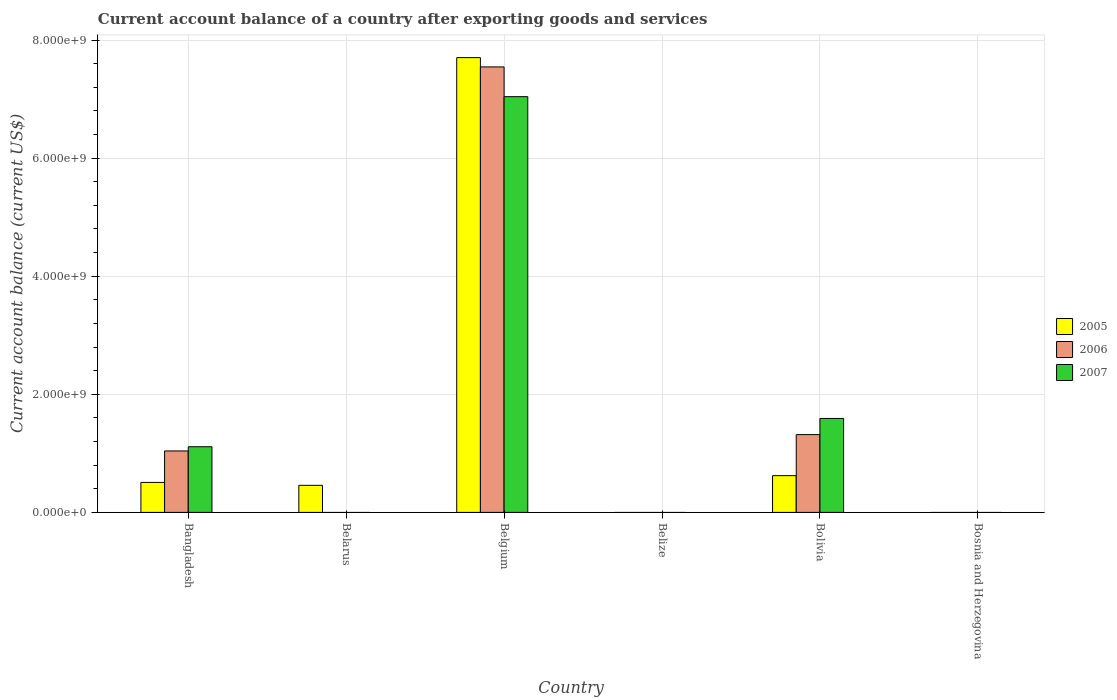How many bars are there on the 6th tick from the left?
Your answer should be very brief. 0. How many bars are there on the 5th tick from the right?
Make the answer very short. 1. What is the label of the 5th group of bars from the left?
Offer a very short reply. Bolivia. In how many cases, is the number of bars for a given country not equal to the number of legend labels?
Give a very brief answer. 3. What is the account balance in 2007 in Bolivia?
Make the answer very short. 1.59e+09. Across all countries, what is the maximum account balance in 2007?
Ensure brevity in your answer.  7.04e+09. Across all countries, what is the minimum account balance in 2007?
Your answer should be compact. 0. What is the total account balance in 2007 in the graph?
Offer a terse response. 9.74e+09. What is the difference between the account balance in 2007 in Bangladesh and that in Belgium?
Your response must be concise. -5.93e+09. What is the difference between the account balance in 2007 in Belarus and the account balance in 2005 in Belgium?
Your answer should be compact. -7.70e+09. What is the average account balance in 2006 per country?
Your response must be concise. 1.65e+09. What is the difference between the account balance of/in 2006 and account balance of/in 2005 in Bolivia?
Offer a very short reply. 6.95e+08. Is the account balance in 2006 in Bangladesh less than that in Belgium?
Your answer should be very brief. Yes. Is the difference between the account balance in 2006 in Bangladesh and Belgium greater than the difference between the account balance in 2005 in Bangladesh and Belgium?
Provide a short and direct response. Yes. What is the difference between the highest and the second highest account balance in 2005?
Provide a succinct answer. 1.15e+08. What is the difference between the highest and the lowest account balance in 2006?
Keep it short and to the point. 7.55e+09. In how many countries, is the account balance in 2005 greater than the average account balance in 2005 taken over all countries?
Offer a very short reply. 1. How many bars are there?
Your response must be concise. 10. How many countries are there in the graph?
Provide a succinct answer. 6. Are the values on the major ticks of Y-axis written in scientific E-notation?
Ensure brevity in your answer.  Yes. What is the title of the graph?
Your response must be concise. Current account balance of a country after exporting goods and services. What is the label or title of the X-axis?
Keep it short and to the point. Country. What is the label or title of the Y-axis?
Offer a very short reply. Current account balance (current US$). What is the Current account balance (current US$) of 2005 in Bangladesh?
Keep it short and to the point. 5.08e+08. What is the Current account balance (current US$) in 2006 in Bangladesh?
Provide a short and direct response. 1.04e+09. What is the Current account balance (current US$) in 2007 in Bangladesh?
Your answer should be very brief. 1.11e+09. What is the Current account balance (current US$) in 2005 in Belarus?
Your response must be concise. 4.59e+08. What is the Current account balance (current US$) in 2005 in Belgium?
Offer a very short reply. 7.70e+09. What is the Current account balance (current US$) in 2006 in Belgium?
Offer a terse response. 7.55e+09. What is the Current account balance (current US$) in 2007 in Belgium?
Offer a very short reply. 7.04e+09. What is the Current account balance (current US$) in 2005 in Belize?
Offer a very short reply. 0. What is the Current account balance (current US$) in 2006 in Belize?
Your answer should be very brief. 0. What is the Current account balance (current US$) of 2007 in Belize?
Offer a very short reply. 0. What is the Current account balance (current US$) of 2005 in Bolivia?
Make the answer very short. 6.22e+08. What is the Current account balance (current US$) in 2006 in Bolivia?
Your response must be concise. 1.32e+09. What is the Current account balance (current US$) in 2007 in Bolivia?
Give a very brief answer. 1.59e+09. Across all countries, what is the maximum Current account balance (current US$) in 2005?
Offer a very short reply. 7.70e+09. Across all countries, what is the maximum Current account balance (current US$) in 2006?
Provide a short and direct response. 7.55e+09. Across all countries, what is the maximum Current account balance (current US$) of 2007?
Offer a very short reply. 7.04e+09. What is the total Current account balance (current US$) of 2005 in the graph?
Make the answer very short. 9.29e+09. What is the total Current account balance (current US$) in 2006 in the graph?
Your answer should be compact. 9.90e+09. What is the total Current account balance (current US$) in 2007 in the graph?
Your answer should be compact. 9.74e+09. What is the difference between the Current account balance (current US$) in 2005 in Bangladesh and that in Belarus?
Your answer should be compact. 4.91e+07. What is the difference between the Current account balance (current US$) in 2005 in Bangladesh and that in Belgium?
Offer a very short reply. -7.19e+09. What is the difference between the Current account balance (current US$) in 2006 in Bangladesh and that in Belgium?
Offer a terse response. -6.50e+09. What is the difference between the Current account balance (current US$) of 2007 in Bangladesh and that in Belgium?
Offer a terse response. -5.93e+09. What is the difference between the Current account balance (current US$) in 2005 in Bangladesh and that in Bolivia?
Offer a very short reply. -1.15e+08. What is the difference between the Current account balance (current US$) of 2006 in Bangladesh and that in Bolivia?
Ensure brevity in your answer.  -2.77e+08. What is the difference between the Current account balance (current US$) in 2007 in Bangladesh and that in Bolivia?
Give a very brief answer. -4.79e+08. What is the difference between the Current account balance (current US$) of 2005 in Belarus and that in Belgium?
Provide a short and direct response. -7.24e+09. What is the difference between the Current account balance (current US$) of 2005 in Belarus and that in Bolivia?
Your answer should be very brief. -1.64e+08. What is the difference between the Current account balance (current US$) of 2005 in Belgium and that in Bolivia?
Offer a terse response. 7.08e+09. What is the difference between the Current account balance (current US$) in 2006 in Belgium and that in Bolivia?
Keep it short and to the point. 6.23e+09. What is the difference between the Current account balance (current US$) of 2007 in Belgium and that in Bolivia?
Your answer should be compact. 5.45e+09. What is the difference between the Current account balance (current US$) in 2005 in Bangladesh and the Current account balance (current US$) in 2006 in Belgium?
Keep it short and to the point. -7.04e+09. What is the difference between the Current account balance (current US$) in 2005 in Bangladesh and the Current account balance (current US$) in 2007 in Belgium?
Provide a succinct answer. -6.53e+09. What is the difference between the Current account balance (current US$) in 2006 in Bangladesh and the Current account balance (current US$) in 2007 in Belgium?
Provide a short and direct response. -6.00e+09. What is the difference between the Current account balance (current US$) in 2005 in Bangladesh and the Current account balance (current US$) in 2006 in Bolivia?
Keep it short and to the point. -8.10e+08. What is the difference between the Current account balance (current US$) of 2005 in Bangladesh and the Current account balance (current US$) of 2007 in Bolivia?
Your answer should be compact. -1.08e+09. What is the difference between the Current account balance (current US$) in 2006 in Bangladesh and the Current account balance (current US$) in 2007 in Bolivia?
Your response must be concise. -5.51e+08. What is the difference between the Current account balance (current US$) in 2005 in Belarus and the Current account balance (current US$) in 2006 in Belgium?
Offer a terse response. -7.09e+09. What is the difference between the Current account balance (current US$) of 2005 in Belarus and the Current account balance (current US$) of 2007 in Belgium?
Ensure brevity in your answer.  -6.58e+09. What is the difference between the Current account balance (current US$) in 2005 in Belarus and the Current account balance (current US$) in 2006 in Bolivia?
Provide a succinct answer. -8.59e+08. What is the difference between the Current account balance (current US$) of 2005 in Belarus and the Current account balance (current US$) of 2007 in Bolivia?
Ensure brevity in your answer.  -1.13e+09. What is the difference between the Current account balance (current US$) in 2005 in Belgium and the Current account balance (current US$) in 2006 in Bolivia?
Ensure brevity in your answer.  6.39e+09. What is the difference between the Current account balance (current US$) in 2005 in Belgium and the Current account balance (current US$) in 2007 in Bolivia?
Your answer should be very brief. 6.11e+09. What is the difference between the Current account balance (current US$) in 2006 in Belgium and the Current account balance (current US$) in 2007 in Bolivia?
Your answer should be very brief. 5.95e+09. What is the average Current account balance (current US$) in 2005 per country?
Make the answer very short. 1.55e+09. What is the average Current account balance (current US$) of 2006 per country?
Your answer should be very brief. 1.65e+09. What is the average Current account balance (current US$) in 2007 per country?
Offer a very short reply. 1.62e+09. What is the difference between the Current account balance (current US$) of 2005 and Current account balance (current US$) of 2006 in Bangladesh?
Your answer should be very brief. -5.33e+08. What is the difference between the Current account balance (current US$) in 2005 and Current account balance (current US$) in 2007 in Bangladesh?
Provide a short and direct response. -6.04e+08. What is the difference between the Current account balance (current US$) of 2006 and Current account balance (current US$) of 2007 in Bangladesh?
Give a very brief answer. -7.13e+07. What is the difference between the Current account balance (current US$) in 2005 and Current account balance (current US$) in 2006 in Belgium?
Your answer should be compact. 1.58e+08. What is the difference between the Current account balance (current US$) in 2005 and Current account balance (current US$) in 2007 in Belgium?
Keep it short and to the point. 6.61e+08. What is the difference between the Current account balance (current US$) of 2006 and Current account balance (current US$) of 2007 in Belgium?
Your response must be concise. 5.04e+08. What is the difference between the Current account balance (current US$) in 2005 and Current account balance (current US$) in 2006 in Bolivia?
Ensure brevity in your answer.  -6.95e+08. What is the difference between the Current account balance (current US$) of 2005 and Current account balance (current US$) of 2007 in Bolivia?
Ensure brevity in your answer.  -9.69e+08. What is the difference between the Current account balance (current US$) in 2006 and Current account balance (current US$) in 2007 in Bolivia?
Provide a succinct answer. -2.74e+08. What is the ratio of the Current account balance (current US$) of 2005 in Bangladesh to that in Belarus?
Keep it short and to the point. 1.11. What is the ratio of the Current account balance (current US$) in 2005 in Bangladesh to that in Belgium?
Your answer should be compact. 0.07. What is the ratio of the Current account balance (current US$) of 2006 in Bangladesh to that in Belgium?
Ensure brevity in your answer.  0.14. What is the ratio of the Current account balance (current US$) in 2007 in Bangladesh to that in Belgium?
Offer a very short reply. 0.16. What is the ratio of the Current account balance (current US$) of 2005 in Bangladesh to that in Bolivia?
Ensure brevity in your answer.  0.82. What is the ratio of the Current account balance (current US$) of 2006 in Bangladesh to that in Bolivia?
Offer a very short reply. 0.79. What is the ratio of the Current account balance (current US$) of 2007 in Bangladesh to that in Bolivia?
Keep it short and to the point. 0.7. What is the ratio of the Current account balance (current US$) in 2005 in Belarus to that in Belgium?
Provide a succinct answer. 0.06. What is the ratio of the Current account balance (current US$) of 2005 in Belarus to that in Bolivia?
Your answer should be compact. 0.74. What is the ratio of the Current account balance (current US$) in 2005 in Belgium to that in Bolivia?
Keep it short and to the point. 12.37. What is the ratio of the Current account balance (current US$) in 2006 in Belgium to that in Bolivia?
Provide a short and direct response. 5.73. What is the ratio of the Current account balance (current US$) of 2007 in Belgium to that in Bolivia?
Offer a very short reply. 4.42. What is the difference between the highest and the second highest Current account balance (current US$) of 2005?
Ensure brevity in your answer.  7.08e+09. What is the difference between the highest and the second highest Current account balance (current US$) of 2006?
Keep it short and to the point. 6.23e+09. What is the difference between the highest and the second highest Current account balance (current US$) in 2007?
Offer a very short reply. 5.45e+09. What is the difference between the highest and the lowest Current account balance (current US$) of 2005?
Provide a succinct answer. 7.70e+09. What is the difference between the highest and the lowest Current account balance (current US$) of 2006?
Give a very brief answer. 7.55e+09. What is the difference between the highest and the lowest Current account balance (current US$) of 2007?
Your answer should be very brief. 7.04e+09. 